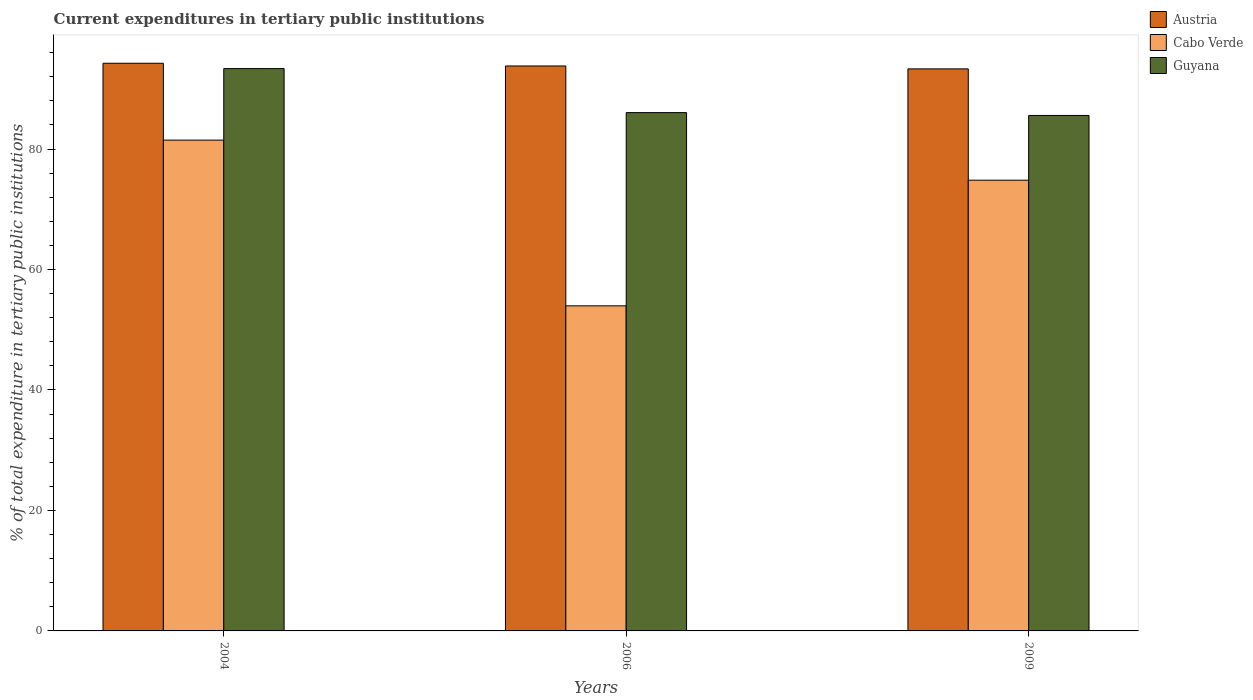How many bars are there on the 1st tick from the right?
Ensure brevity in your answer.  3. What is the label of the 2nd group of bars from the left?
Your response must be concise. 2006. In how many cases, is the number of bars for a given year not equal to the number of legend labels?
Give a very brief answer. 0. What is the current expenditures in tertiary public institutions in Cabo Verde in 2006?
Keep it short and to the point. 53.97. Across all years, what is the maximum current expenditures in tertiary public institutions in Cabo Verde?
Provide a succinct answer. 81.48. Across all years, what is the minimum current expenditures in tertiary public institutions in Cabo Verde?
Provide a succinct answer. 53.97. In which year was the current expenditures in tertiary public institutions in Cabo Verde maximum?
Offer a terse response. 2004. What is the total current expenditures in tertiary public institutions in Guyana in the graph?
Your response must be concise. 264.96. What is the difference between the current expenditures in tertiary public institutions in Austria in 2004 and that in 2009?
Make the answer very short. 0.93. What is the difference between the current expenditures in tertiary public institutions in Austria in 2009 and the current expenditures in tertiary public institutions in Guyana in 2004?
Your response must be concise. -0.05. What is the average current expenditures in tertiary public institutions in Cabo Verde per year?
Your answer should be compact. 70.09. In the year 2006, what is the difference between the current expenditures in tertiary public institutions in Austria and current expenditures in tertiary public institutions in Guyana?
Provide a succinct answer. 7.74. What is the ratio of the current expenditures in tertiary public institutions in Cabo Verde in 2004 to that in 2009?
Offer a terse response. 1.09. Is the current expenditures in tertiary public institutions in Guyana in 2004 less than that in 2006?
Offer a terse response. No. Is the difference between the current expenditures in tertiary public institutions in Austria in 2004 and 2006 greater than the difference between the current expenditures in tertiary public institutions in Guyana in 2004 and 2006?
Your answer should be very brief. No. What is the difference between the highest and the second highest current expenditures in tertiary public institutions in Cabo Verde?
Your answer should be compact. 6.65. What is the difference between the highest and the lowest current expenditures in tertiary public institutions in Cabo Verde?
Provide a short and direct response. 27.51. In how many years, is the current expenditures in tertiary public institutions in Guyana greater than the average current expenditures in tertiary public institutions in Guyana taken over all years?
Provide a succinct answer. 1. Is the sum of the current expenditures in tertiary public institutions in Guyana in 2004 and 2009 greater than the maximum current expenditures in tertiary public institutions in Cabo Verde across all years?
Make the answer very short. Yes. What does the 3rd bar from the left in 2009 represents?
Offer a very short reply. Guyana. What does the 2nd bar from the right in 2009 represents?
Your answer should be compact. Cabo Verde. How many bars are there?
Provide a succinct answer. 9. How many years are there in the graph?
Your response must be concise. 3. Are the values on the major ticks of Y-axis written in scientific E-notation?
Your answer should be compact. No. Does the graph contain any zero values?
Your answer should be compact. No. How many legend labels are there?
Your response must be concise. 3. How are the legend labels stacked?
Provide a short and direct response. Vertical. What is the title of the graph?
Offer a terse response. Current expenditures in tertiary public institutions. Does "Saudi Arabia" appear as one of the legend labels in the graph?
Ensure brevity in your answer.  No. What is the label or title of the X-axis?
Ensure brevity in your answer.  Years. What is the label or title of the Y-axis?
Offer a terse response. % of total expenditure in tertiary public institutions. What is the % of total expenditure in tertiary public institutions of Austria in 2004?
Your answer should be very brief. 94.23. What is the % of total expenditure in tertiary public institutions in Cabo Verde in 2004?
Offer a very short reply. 81.48. What is the % of total expenditure in tertiary public institutions of Guyana in 2004?
Offer a terse response. 93.35. What is the % of total expenditure in tertiary public institutions in Austria in 2006?
Give a very brief answer. 93.78. What is the % of total expenditure in tertiary public institutions of Cabo Verde in 2006?
Your answer should be very brief. 53.97. What is the % of total expenditure in tertiary public institutions of Guyana in 2006?
Give a very brief answer. 86.04. What is the % of total expenditure in tertiary public institutions of Austria in 2009?
Provide a short and direct response. 93.3. What is the % of total expenditure in tertiary public institutions of Cabo Verde in 2009?
Make the answer very short. 74.82. What is the % of total expenditure in tertiary public institutions in Guyana in 2009?
Keep it short and to the point. 85.57. Across all years, what is the maximum % of total expenditure in tertiary public institutions of Austria?
Give a very brief answer. 94.23. Across all years, what is the maximum % of total expenditure in tertiary public institutions in Cabo Verde?
Ensure brevity in your answer.  81.48. Across all years, what is the maximum % of total expenditure in tertiary public institutions of Guyana?
Ensure brevity in your answer.  93.35. Across all years, what is the minimum % of total expenditure in tertiary public institutions in Austria?
Give a very brief answer. 93.3. Across all years, what is the minimum % of total expenditure in tertiary public institutions of Cabo Verde?
Your answer should be compact. 53.97. Across all years, what is the minimum % of total expenditure in tertiary public institutions of Guyana?
Give a very brief answer. 85.57. What is the total % of total expenditure in tertiary public institutions in Austria in the graph?
Your response must be concise. 281.32. What is the total % of total expenditure in tertiary public institutions in Cabo Verde in the graph?
Give a very brief answer. 210.26. What is the total % of total expenditure in tertiary public institutions in Guyana in the graph?
Your answer should be very brief. 264.96. What is the difference between the % of total expenditure in tertiary public institutions in Austria in 2004 and that in 2006?
Your answer should be very brief. 0.45. What is the difference between the % of total expenditure in tertiary public institutions in Cabo Verde in 2004 and that in 2006?
Provide a short and direct response. 27.51. What is the difference between the % of total expenditure in tertiary public institutions of Guyana in 2004 and that in 2006?
Ensure brevity in your answer.  7.31. What is the difference between the % of total expenditure in tertiary public institutions of Austria in 2004 and that in 2009?
Keep it short and to the point. 0.93. What is the difference between the % of total expenditure in tertiary public institutions of Cabo Verde in 2004 and that in 2009?
Ensure brevity in your answer.  6.65. What is the difference between the % of total expenditure in tertiary public institutions in Guyana in 2004 and that in 2009?
Keep it short and to the point. 7.78. What is the difference between the % of total expenditure in tertiary public institutions in Austria in 2006 and that in 2009?
Offer a very short reply. 0.48. What is the difference between the % of total expenditure in tertiary public institutions in Cabo Verde in 2006 and that in 2009?
Keep it short and to the point. -20.86. What is the difference between the % of total expenditure in tertiary public institutions in Guyana in 2006 and that in 2009?
Give a very brief answer. 0.47. What is the difference between the % of total expenditure in tertiary public institutions in Austria in 2004 and the % of total expenditure in tertiary public institutions in Cabo Verde in 2006?
Make the answer very short. 40.27. What is the difference between the % of total expenditure in tertiary public institutions of Austria in 2004 and the % of total expenditure in tertiary public institutions of Guyana in 2006?
Give a very brief answer. 8.19. What is the difference between the % of total expenditure in tertiary public institutions in Cabo Verde in 2004 and the % of total expenditure in tertiary public institutions in Guyana in 2006?
Keep it short and to the point. -4.57. What is the difference between the % of total expenditure in tertiary public institutions of Austria in 2004 and the % of total expenditure in tertiary public institutions of Cabo Verde in 2009?
Make the answer very short. 19.41. What is the difference between the % of total expenditure in tertiary public institutions in Austria in 2004 and the % of total expenditure in tertiary public institutions in Guyana in 2009?
Provide a short and direct response. 8.66. What is the difference between the % of total expenditure in tertiary public institutions of Cabo Verde in 2004 and the % of total expenditure in tertiary public institutions of Guyana in 2009?
Provide a succinct answer. -4.09. What is the difference between the % of total expenditure in tertiary public institutions in Austria in 2006 and the % of total expenditure in tertiary public institutions in Cabo Verde in 2009?
Offer a terse response. 18.96. What is the difference between the % of total expenditure in tertiary public institutions of Austria in 2006 and the % of total expenditure in tertiary public institutions of Guyana in 2009?
Provide a short and direct response. 8.21. What is the difference between the % of total expenditure in tertiary public institutions in Cabo Verde in 2006 and the % of total expenditure in tertiary public institutions in Guyana in 2009?
Keep it short and to the point. -31.6. What is the average % of total expenditure in tertiary public institutions of Austria per year?
Offer a very short reply. 93.77. What is the average % of total expenditure in tertiary public institutions of Cabo Verde per year?
Provide a succinct answer. 70.09. What is the average % of total expenditure in tertiary public institutions in Guyana per year?
Offer a terse response. 88.32. In the year 2004, what is the difference between the % of total expenditure in tertiary public institutions of Austria and % of total expenditure in tertiary public institutions of Cabo Verde?
Offer a very short reply. 12.76. In the year 2004, what is the difference between the % of total expenditure in tertiary public institutions of Austria and % of total expenditure in tertiary public institutions of Guyana?
Your answer should be compact. 0.88. In the year 2004, what is the difference between the % of total expenditure in tertiary public institutions in Cabo Verde and % of total expenditure in tertiary public institutions in Guyana?
Offer a terse response. -11.87. In the year 2006, what is the difference between the % of total expenditure in tertiary public institutions in Austria and % of total expenditure in tertiary public institutions in Cabo Verde?
Your answer should be very brief. 39.82. In the year 2006, what is the difference between the % of total expenditure in tertiary public institutions in Austria and % of total expenditure in tertiary public institutions in Guyana?
Give a very brief answer. 7.74. In the year 2006, what is the difference between the % of total expenditure in tertiary public institutions of Cabo Verde and % of total expenditure in tertiary public institutions of Guyana?
Ensure brevity in your answer.  -32.08. In the year 2009, what is the difference between the % of total expenditure in tertiary public institutions in Austria and % of total expenditure in tertiary public institutions in Cabo Verde?
Offer a very short reply. 18.48. In the year 2009, what is the difference between the % of total expenditure in tertiary public institutions in Austria and % of total expenditure in tertiary public institutions in Guyana?
Ensure brevity in your answer.  7.73. In the year 2009, what is the difference between the % of total expenditure in tertiary public institutions of Cabo Verde and % of total expenditure in tertiary public institutions of Guyana?
Make the answer very short. -10.75. What is the ratio of the % of total expenditure in tertiary public institutions of Austria in 2004 to that in 2006?
Your answer should be compact. 1. What is the ratio of the % of total expenditure in tertiary public institutions in Cabo Verde in 2004 to that in 2006?
Provide a short and direct response. 1.51. What is the ratio of the % of total expenditure in tertiary public institutions of Guyana in 2004 to that in 2006?
Your response must be concise. 1.08. What is the ratio of the % of total expenditure in tertiary public institutions of Austria in 2004 to that in 2009?
Provide a short and direct response. 1.01. What is the ratio of the % of total expenditure in tertiary public institutions in Cabo Verde in 2004 to that in 2009?
Provide a short and direct response. 1.09. What is the ratio of the % of total expenditure in tertiary public institutions of Austria in 2006 to that in 2009?
Offer a very short reply. 1.01. What is the ratio of the % of total expenditure in tertiary public institutions of Cabo Verde in 2006 to that in 2009?
Your answer should be compact. 0.72. What is the ratio of the % of total expenditure in tertiary public institutions in Guyana in 2006 to that in 2009?
Your answer should be compact. 1.01. What is the difference between the highest and the second highest % of total expenditure in tertiary public institutions of Austria?
Offer a very short reply. 0.45. What is the difference between the highest and the second highest % of total expenditure in tertiary public institutions in Cabo Verde?
Provide a succinct answer. 6.65. What is the difference between the highest and the second highest % of total expenditure in tertiary public institutions in Guyana?
Your response must be concise. 7.31. What is the difference between the highest and the lowest % of total expenditure in tertiary public institutions of Austria?
Your answer should be very brief. 0.93. What is the difference between the highest and the lowest % of total expenditure in tertiary public institutions of Cabo Verde?
Ensure brevity in your answer.  27.51. What is the difference between the highest and the lowest % of total expenditure in tertiary public institutions of Guyana?
Make the answer very short. 7.78. 